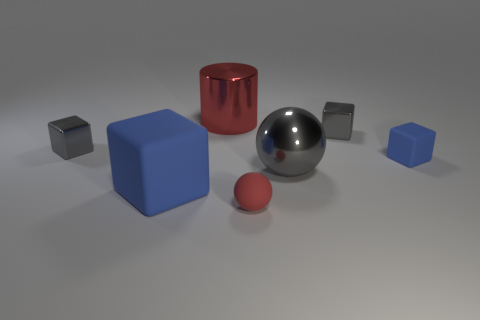How is the lighting in the scene affecting the appearance of the objects? The scene is lit in such a way that soft shadows are cast onto the ground, suggesting a diffuse light source, possibly from above. This lighting emphasizes the three-dimensional form of each object and brings out the textures and materials; for example, the shiny surfaces reflect the light strongly and have crisp, clear reflections, while the matte objects display more subtle shading. 